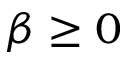Convert formula to latex. <formula><loc_0><loc_0><loc_500><loc_500>\beta \geq 0</formula> 